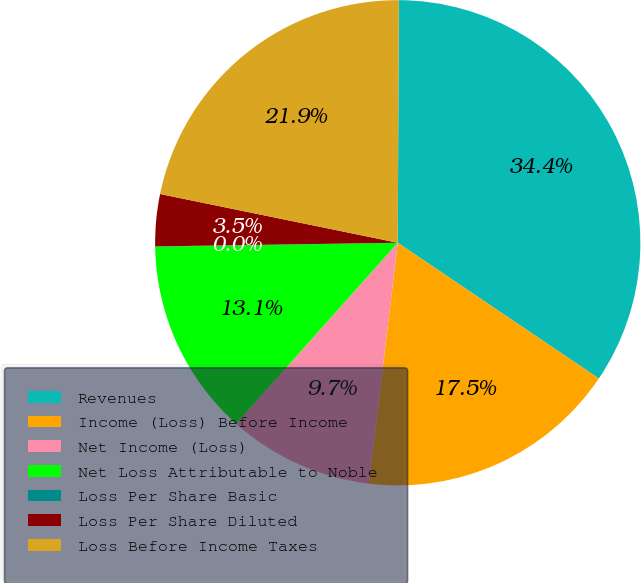<chart> <loc_0><loc_0><loc_500><loc_500><pie_chart><fcel>Revenues<fcel>Income (Loss) Before Income<fcel>Net Income (Loss)<fcel>Net Loss Attributable to Noble<fcel>Loss Per Share Basic<fcel>Loss Per Share Diluted<fcel>Loss Before Income Taxes<nl><fcel>34.38%<fcel>17.45%<fcel>9.7%<fcel>13.14%<fcel>0.02%<fcel>3.46%<fcel>21.85%<nl></chart> 